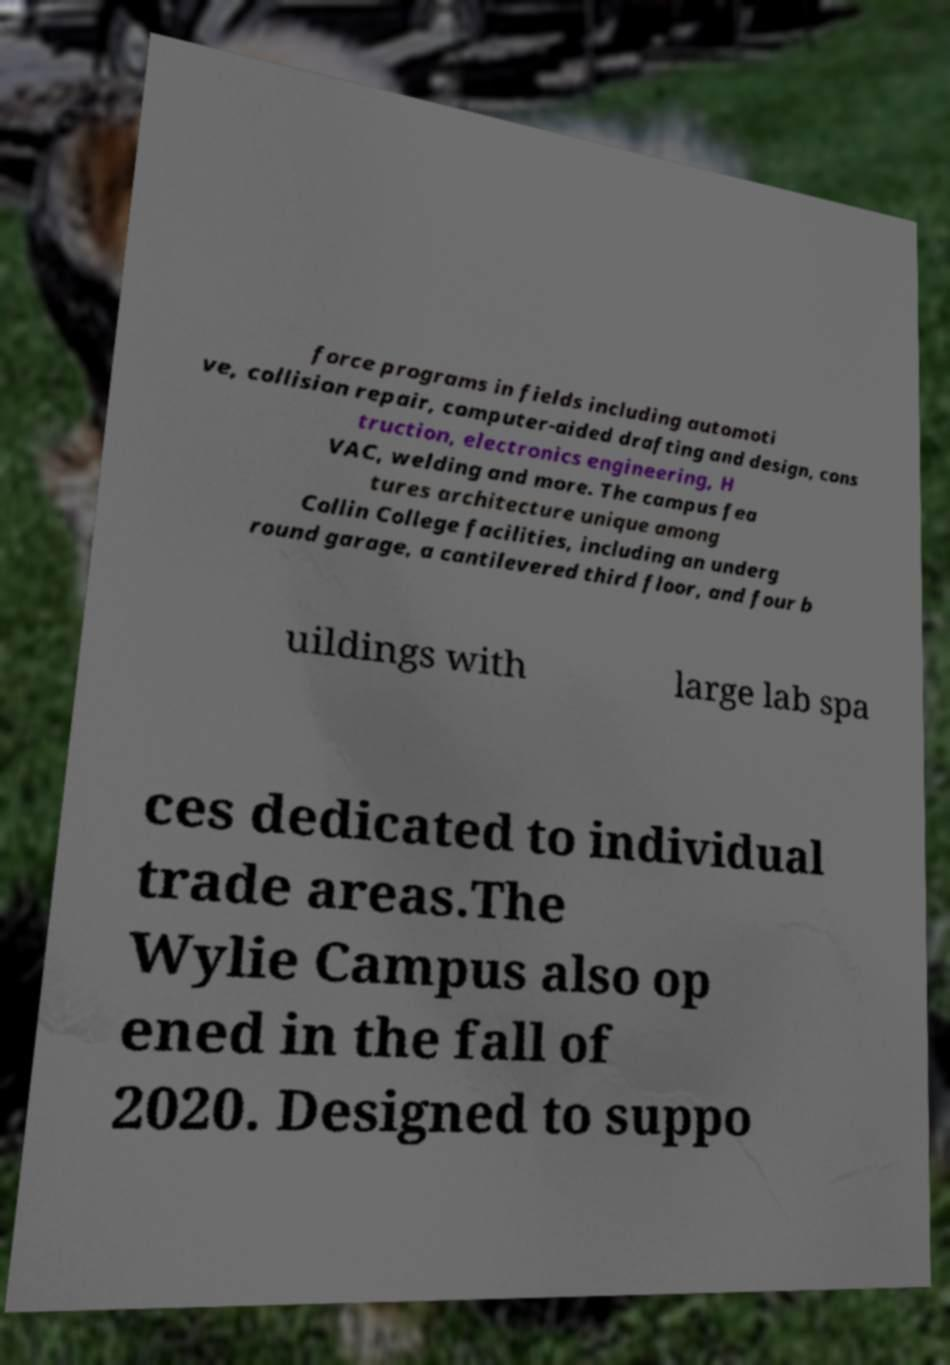Please identify and transcribe the text found in this image. force programs in fields including automoti ve, collision repair, computer-aided drafting and design, cons truction, electronics engineering, H VAC, welding and more. The campus fea tures architecture unique among Collin College facilities, including an underg round garage, a cantilevered third floor, and four b uildings with large lab spa ces dedicated to individual trade areas.The Wylie Campus also op ened in the fall of 2020. Designed to suppo 